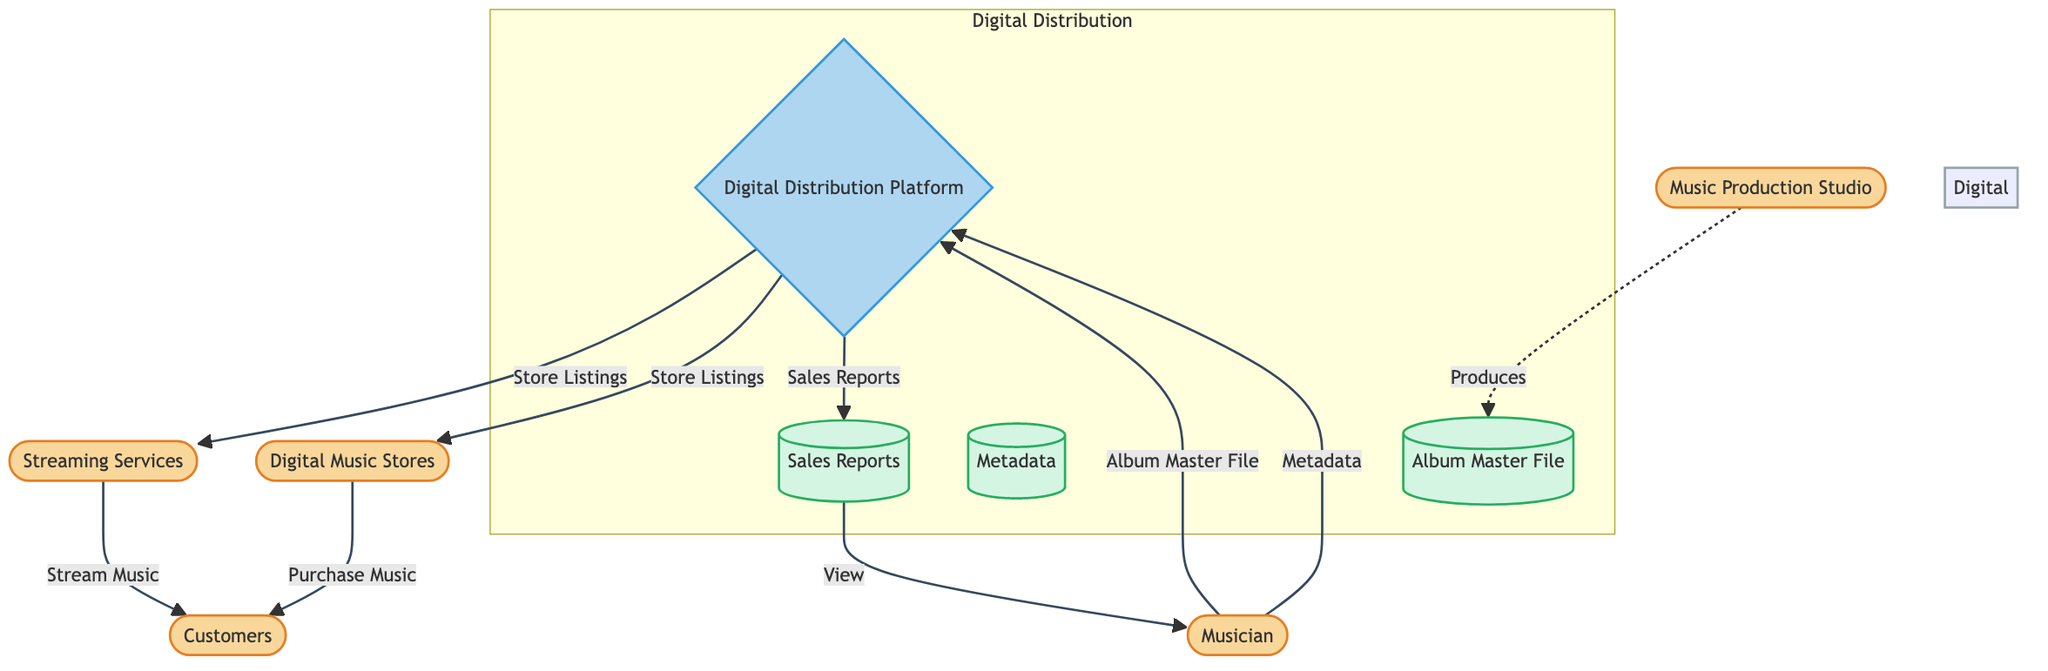What is the external entity that creates the albums? The diagram identifies "Musician" as the external entity responsible for creating the Nordic folk music albums. This is evident as it is labeled as an external entity at the top of the diagram.
Answer: Musician How many processes are represented in the diagram? The diagram contains one process labeled as "Digital Distribution Platform." This can be found in the center of the flowchart indicating the main service for distribution.
Answer: 1 What is the output of the Digital Distribution Platform? The diagram shows two outputs from the "Digital Distribution Platform" process: "Store Listings" and "Sales Reports," indicating what results from this process.
Answer: Store Listings, Sales Reports Which external entities interact with Customers? The diagram lists two external entities that interact with Customers: "Streaming Services" and "Digital Music Stores." Both are shown connecting to the Customers node as they either provide streaming or purchasing options.
Answer: Streaming Services, Digital Music Stores What type of data store holds the final audio files? According to the diagram, the "Album Master File" is identified as the data store that holds the final mastered audio files of the album. Its label indicates it is a repository for this data.
Answer: Album Master File What flows from the Digital Distribution Platform to the Customers? The diagram indicates that the Digital Distribution Platform outputs "Store Listings" to both Streaming Services and Digital Music Stores, which then allows Customers to stream or purchase music. Therefore, these listings enable Customer interactions.
Answer: Store Listings What does the Digital Distribution Platform receive from the Musician? The diagram specifies that the Digital Distribution Platform receives two key inputs from the Musician: "Album Master File" and "Metadata." These inputs are necessary for the distribution process.
Answer: Album Master File, Metadata What is the purpose of Sales Reports? The diagram indicates that "Sales Reports," generated by the Digital Distribution Platform, provide detailed information about the sales and streams of the albums, serving as a feedback mechanism to inform the Musician.
Answer: Detailed information about sales and streams 